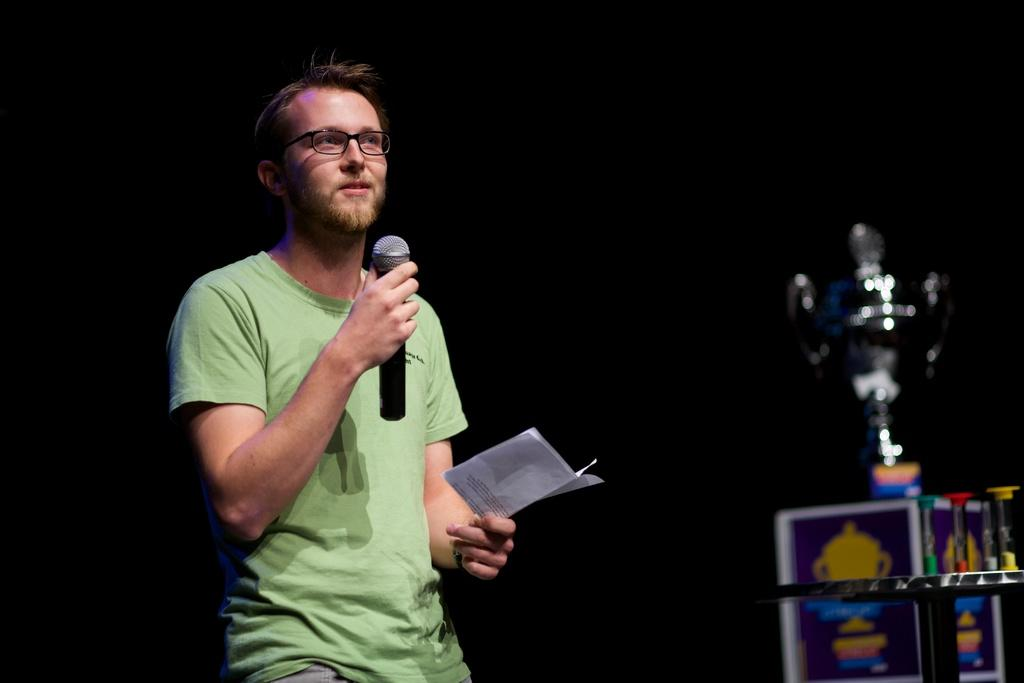What is the man in the image holding in his hand? The man is holding a paper and a microphone in the image. What might the man be doing with the microphone? The man might be using the microphone to speak or make an announcement. What is located on the box in the image? There is a trophy on a box in the image. What objects can be seen on the table in the image? There are objects on a table in the image, but their specific details are not mentioned in the facts. What is the color of the background in the image? The background of the image is dark. What type of birds can be seen flying in the image? There are no birds visible in the image. What idea does the man have for the history project in the image? The facts provided do not mention any history project or idea related to the man in the image. 